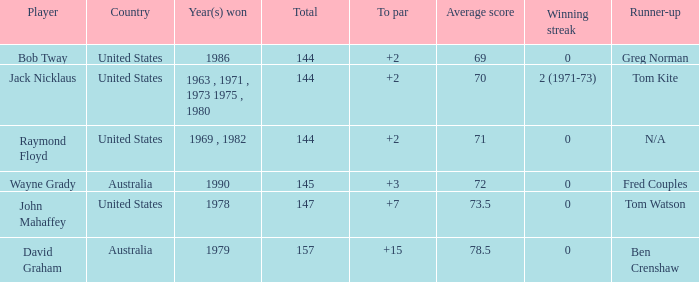In 1978, what was the average score per round for the victorious player? 147.0. 